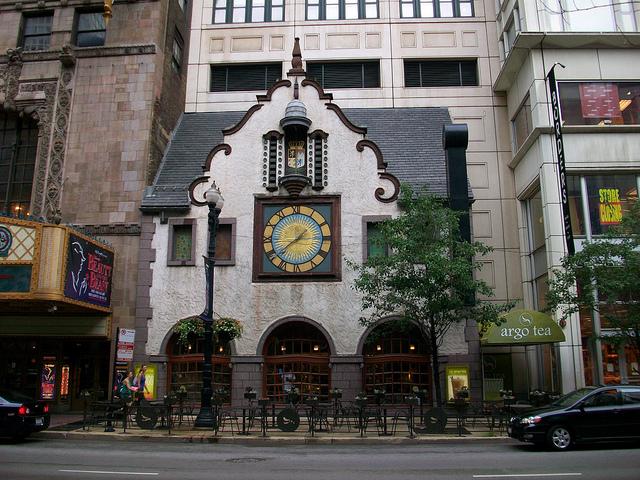Is this in America?
Give a very brief answer. No. Where is the cafe?
Answer briefly. London. Is this a new or ancient clock?
Be succinct. Ancient. What color is the right car?
Give a very brief answer. Black. Are there cars on the road?
Answer briefly. Yes. Where is the clock?
Write a very short answer. On building. 